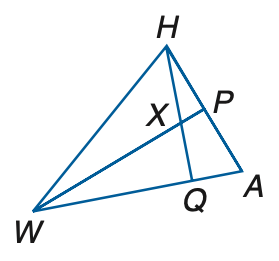Answer the mathemtical geometry problem and directly provide the correct option letter.
Question: If W P is a perpendicular bisector, m \angle W H A = 8 q + 17, m \angle H W P = 10 + q, A P = 6 r + 4, and P H = 22 + 3 r, find q.
Choices: A: 5 B: 6 C: 7 D: 8 C 